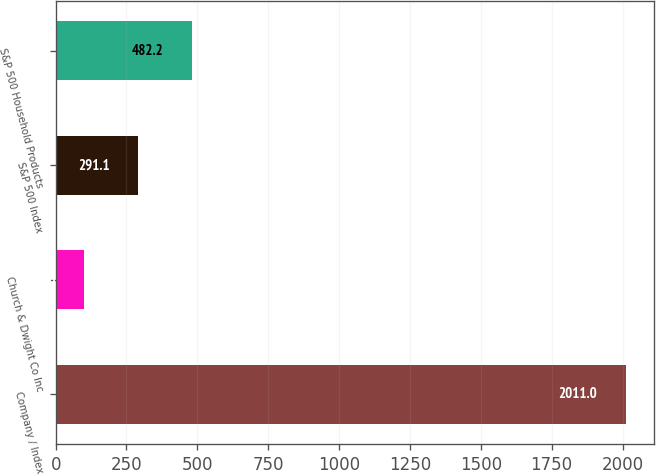<chart> <loc_0><loc_0><loc_500><loc_500><bar_chart><fcel>Company / Index<fcel>Church & Dwight Co Inc<fcel>S&P 500 Index<fcel>S&P 500 Household Products<nl><fcel>2011<fcel>100<fcel>291.1<fcel>482.2<nl></chart> 